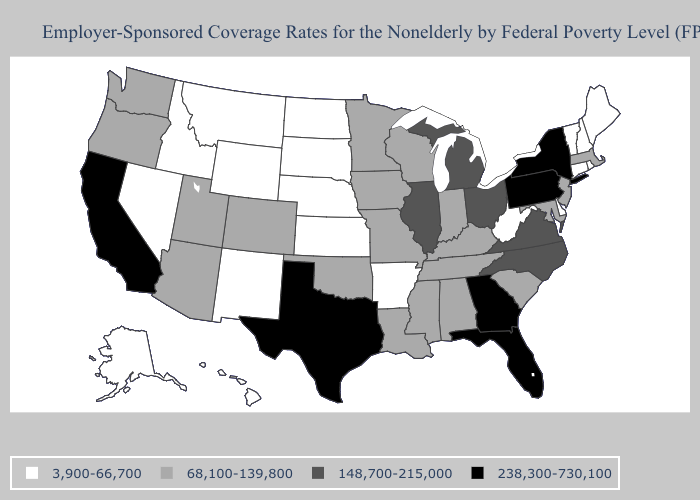What is the value of Hawaii?
Keep it brief. 3,900-66,700. Name the states that have a value in the range 148,700-215,000?
Be succinct. Illinois, Michigan, North Carolina, Ohio, Virginia. Does Massachusetts have the lowest value in the USA?
Write a very short answer. No. Which states have the highest value in the USA?
Give a very brief answer. California, Florida, Georgia, New York, Pennsylvania, Texas. What is the value of Utah?
Answer briefly. 68,100-139,800. Name the states that have a value in the range 68,100-139,800?
Keep it brief. Alabama, Arizona, Colorado, Indiana, Iowa, Kentucky, Louisiana, Maryland, Massachusetts, Minnesota, Mississippi, Missouri, New Jersey, Oklahoma, Oregon, South Carolina, Tennessee, Utah, Washington, Wisconsin. Which states have the lowest value in the South?
Concise answer only. Arkansas, Delaware, West Virginia. How many symbols are there in the legend?
Answer briefly. 4. What is the value of Pennsylvania?
Concise answer only. 238,300-730,100. Does Wyoming have the lowest value in the West?
Keep it brief. Yes. Name the states that have a value in the range 148,700-215,000?
Short answer required. Illinois, Michigan, North Carolina, Ohio, Virginia. Name the states that have a value in the range 68,100-139,800?
Short answer required. Alabama, Arizona, Colorado, Indiana, Iowa, Kentucky, Louisiana, Maryland, Massachusetts, Minnesota, Mississippi, Missouri, New Jersey, Oklahoma, Oregon, South Carolina, Tennessee, Utah, Washington, Wisconsin. What is the value of Ohio?
Keep it brief. 148,700-215,000. Name the states that have a value in the range 148,700-215,000?
Answer briefly. Illinois, Michigan, North Carolina, Ohio, Virginia. Name the states that have a value in the range 68,100-139,800?
Quick response, please. Alabama, Arizona, Colorado, Indiana, Iowa, Kentucky, Louisiana, Maryland, Massachusetts, Minnesota, Mississippi, Missouri, New Jersey, Oklahoma, Oregon, South Carolina, Tennessee, Utah, Washington, Wisconsin. 